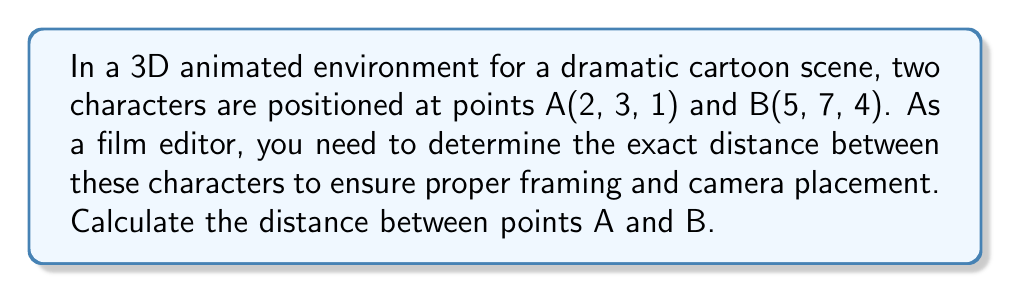Can you solve this math problem? To find the distance between two points in a 3D space, we use the 3D distance formula, which is derived from the Pythagorean theorem:

$$d = \sqrt{(x_2-x_1)^2 + (y_2-y_1)^2 + (z_2-z_1)^2}$$

Where $(x_1, y_1, z_1)$ are the coordinates of point A and $(x_2, y_2, z_2)$ are the coordinates of point B.

Given:
Point A(2, 3, 1)
Point B(5, 7, 4)

Step 1: Substitute the coordinates into the formula:
$$d = \sqrt{(5-2)^2 + (7-3)^2 + (4-1)^2}$$

Step 2: Calculate the differences inside the parentheses:
$$d = \sqrt{3^2 + 4^2 + 3^2}$$

Step 3: Square the differences:
$$d = \sqrt{9 + 16 + 9}$$

Step 4: Add the squared differences:
$$d = \sqrt{34}$$

Step 5: Calculate the square root:
$$d \approx 5.83$$

Therefore, the distance between the two characters in the 3D animated environment is approximately 5.83 units.
Answer: $\sqrt{34} \approx 5.83$ units 